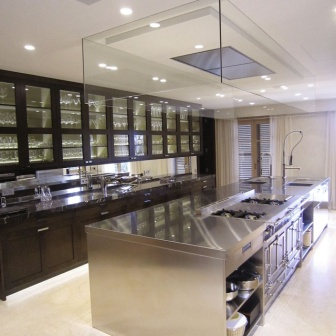Can you describe the design style of this kitchen? This kitchen employs a contemporary design style characterized by clean, sleek lines and a minimalist approach. The use of stainless steel and dark wood cabinetry creates a luxurious yet modern feel. The strategic placement of the lighting and the layout are functionally and aesthetically pleasing, pointing to a modernist influence that prioritizes space utilization and visual appeal. 